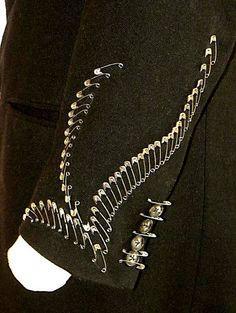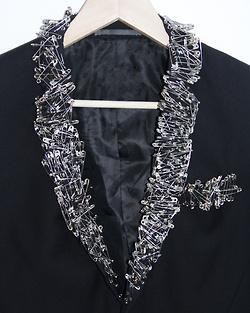The first image is the image on the left, the second image is the image on the right. For the images displayed, is the sentence "An image shows an item made of pins displayed around the neck of something." factually correct? Answer yes or no. Yes. 